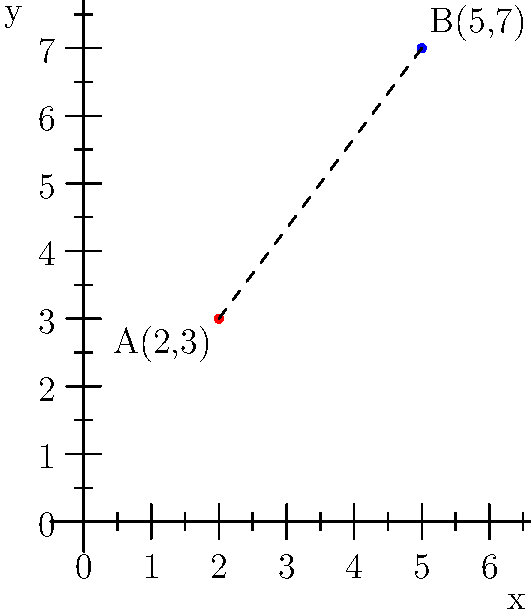In a landmark criminal case, two key pieces of evidence were found at different locations in a coordinate system representing the crime scene. Evidence A was discovered at point (2,3), and evidence B was found at point (5,7). As the defense attorney, you need to determine the straight-line distance between these two pieces of evidence to challenge the prosecution's timeline. Using the distance formula, calculate the distance between points A and B to the nearest hundredth of a unit. To find the distance between two points, we use the distance formula:

$$d = \sqrt{(x_2-x_1)^2 + (y_2-y_1)^2}$$

Where $(x_1,y_1)$ is the first point and $(x_2,y_2)$ is the second point.

Given:
Point A: $(2,3)$
Point B: $(5,7)$

Step 1: Identify the coordinates
$x_1 = 2$, $y_1 = 3$
$x_2 = 5$, $y_2 = 7$

Step 2: Plug the values into the distance formula
$$d = \sqrt{(5-2)^2 + (7-3)^2}$$

Step 3: Simplify the expressions inside the parentheses
$$d = \sqrt{3^2 + 4^2}$$

Step 4: Calculate the squares
$$d = \sqrt{9 + 16}$$

Step 5: Add the values under the square root
$$d = \sqrt{25}$$

Step 6: Calculate the square root
$$d = 5$$

Therefore, the distance between points A and B is 5 units.
Answer: 5 units 